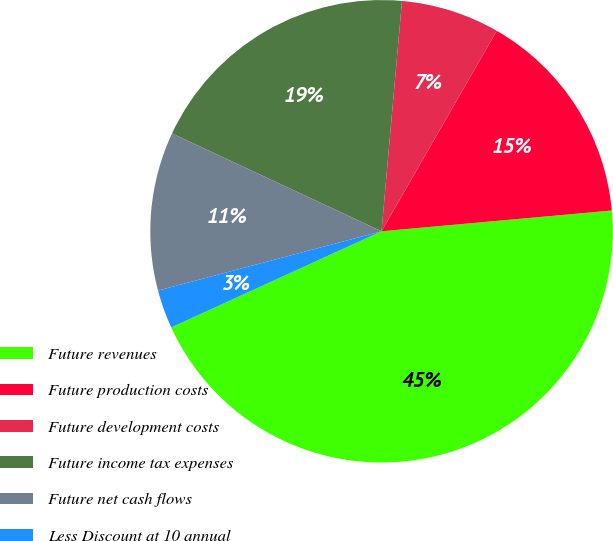Convert chart. <chart><loc_0><loc_0><loc_500><loc_500><pie_chart><fcel>Future revenues<fcel>Future production costs<fcel>Future development costs<fcel>Future income tax expenses<fcel>Future net cash flows<fcel>Less Discount at 10 annual<nl><fcel>44.61%<fcel>15.27%<fcel>6.89%<fcel>19.46%<fcel>11.08%<fcel>2.7%<nl></chart> 